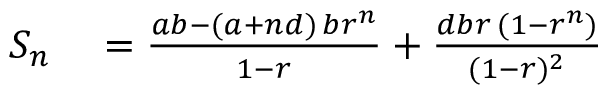Convert formula to latex. <formula><loc_0><loc_0><loc_500><loc_500>\begin{array} { r l } { S _ { n } } & = { \frac { a b - ( a + n d ) \, b r ^ { n } } { 1 - r } } + { \frac { d b r \, ( 1 - r ^ { n } ) } { ( 1 - r ) ^ { 2 } } } } \end{array}</formula> 